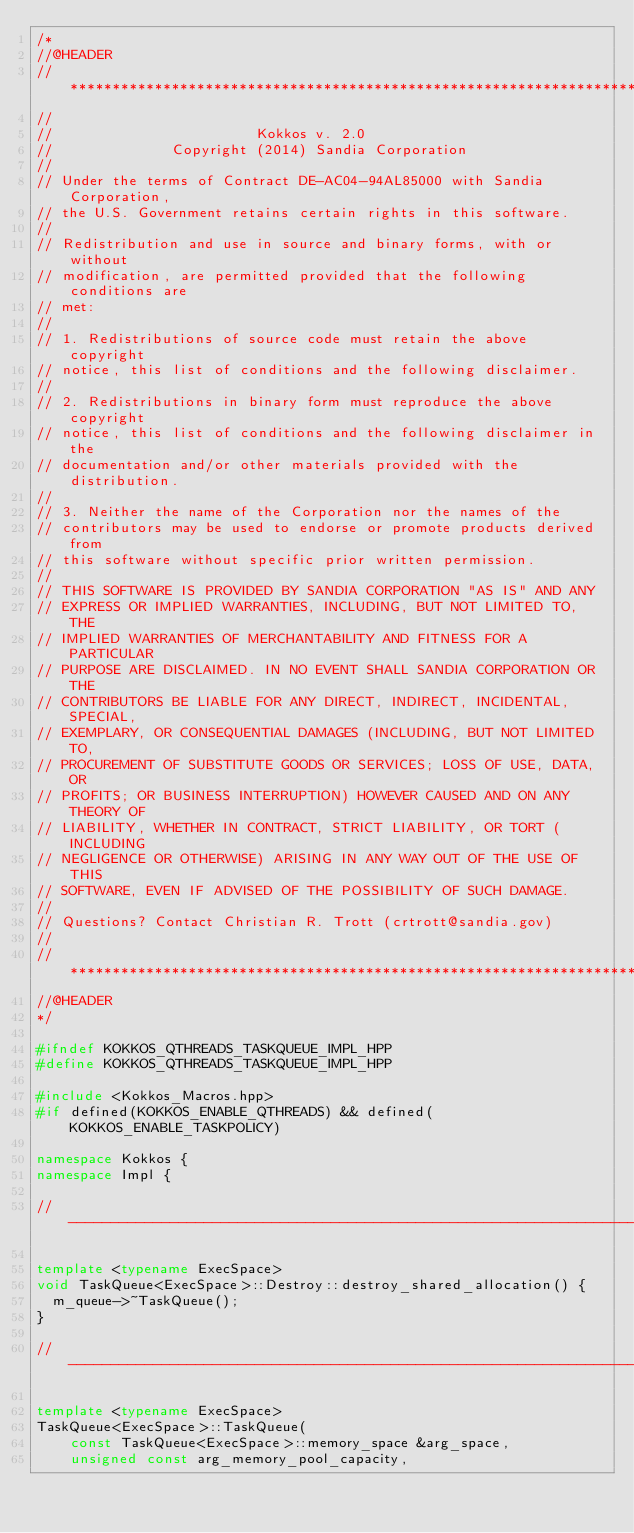<code> <loc_0><loc_0><loc_500><loc_500><_C++_>/*
//@HEADER
// ************************************************************************
//
//                        Kokkos v. 2.0
//              Copyright (2014) Sandia Corporation
//
// Under the terms of Contract DE-AC04-94AL85000 with Sandia Corporation,
// the U.S. Government retains certain rights in this software.
//
// Redistribution and use in source and binary forms, with or without
// modification, are permitted provided that the following conditions are
// met:
//
// 1. Redistributions of source code must retain the above copyright
// notice, this list of conditions and the following disclaimer.
//
// 2. Redistributions in binary form must reproduce the above copyright
// notice, this list of conditions and the following disclaimer in the
// documentation and/or other materials provided with the distribution.
//
// 3. Neither the name of the Corporation nor the names of the
// contributors may be used to endorse or promote products derived from
// this software without specific prior written permission.
//
// THIS SOFTWARE IS PROVIDED BY SANDIA CORPORATION "AS IS" AND ANY
// EXPRESS OR IMPLIED WARRANTIES, INCLUDING, BUT NOT LIMITED TO, THE
// IMPLIED WARRANTIES OF MERCHANTABILITY AND FITNESS FOR A PARTICULAR
// PURPOSE ARE DISCLAIMED. IN NO EVENT SHALL SANDIA CORPORATION OR THE
// CONTRIBUTORS BE LIABLE FOR ANY DIRECT, INDIRECT, INCIDENTAL, SPECIAL,
// EXEMPLARY, OR CONSEQUENTIAL DAMAGES (INCLUDING, BUT NOT LIMITED TO,
// PROCUREMENT OF SUBSTITUTE GOODS OR SERVICES; LOSS OF USE, DATA, OR
// PROFITS; OR BUSINESS INTERRUPTION) HOWEVER CAUSED AND ON ANY THEORY OF
// LIABILITY, WHETHER IN CONTRACT, STRICT LIABILITY, OR TORT (INCLUDING
// NEGLIGENCE OR OTHERWISE) ARISING IN ANY WAY OUT OF THE USE OF THIS
// SOFTWARE, EVEN IF ADVISED OF THE POSSIBILITY OF SUCH DAMAGE.
//
// Questions? Contact Christian R. Trott (crtrott@sandia.gov)
//
// ************************************************************************
//@HEADER
*/

#ifndef KOKKOS_QTHREADS_TASKQUEUE_IMPL_HPP
#define KOKKOS_QTHREADS_TASKQUEUE_IMPL_HPP

#include <Kokkos_Macros.hpp>
#if defined(KOKKOS_ENABLE_QTHREADS) && defined(KOKKOS_ENABLE_TASKPOLICY)

namespace Kokkos {
namespace Impl {

//----------------------------------------------------------------------------

template <typename ExecSpace>
void TaskQueue<ExecSpace>::Destroy::destroy_shared_allocation() {
  m_queue->~TaskQueue();
}

//----------------------------------------------------------------------------

template <typename ExecSpace>
TaskQueue<ExecSpace>::TaskQueue(
    const TaskQueue<ExecSpace>::memory_space &arg_space,
    unsigned const arg_memory_pool_capacity,</code> 